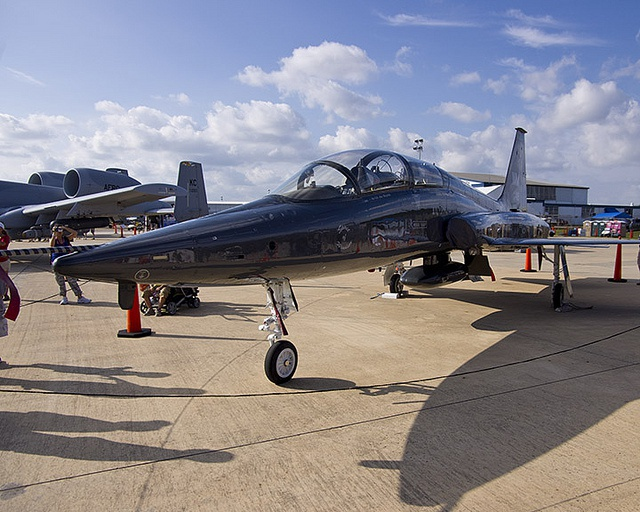Describe the objects in this image and their specific colors. I can see airplane in darkgray, black, gray, and navy tones, airplane in darkgray, navy, black, gray, and darkblue tones, and people in darkgray, black, gray, and maroon tones in this image. 